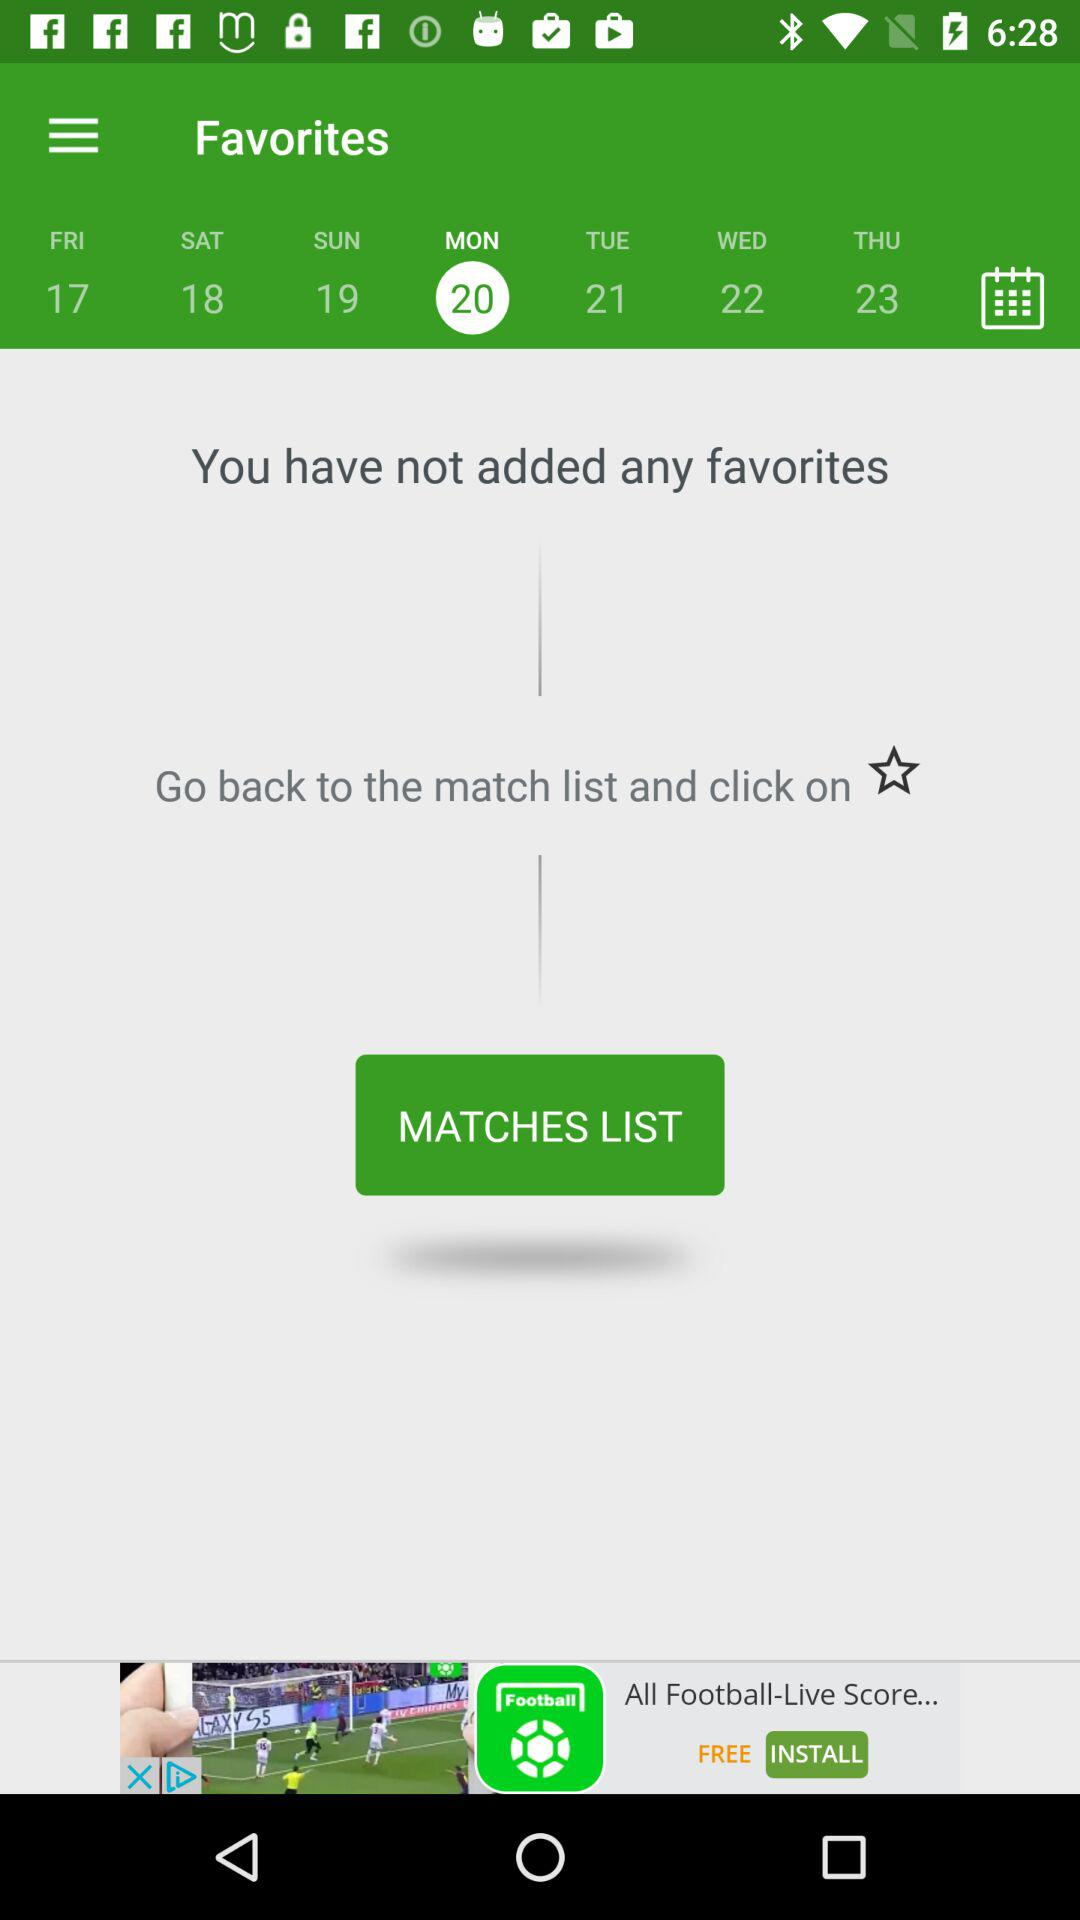How many favorites do I have?
Answer the question using a single word or phrase. 0 